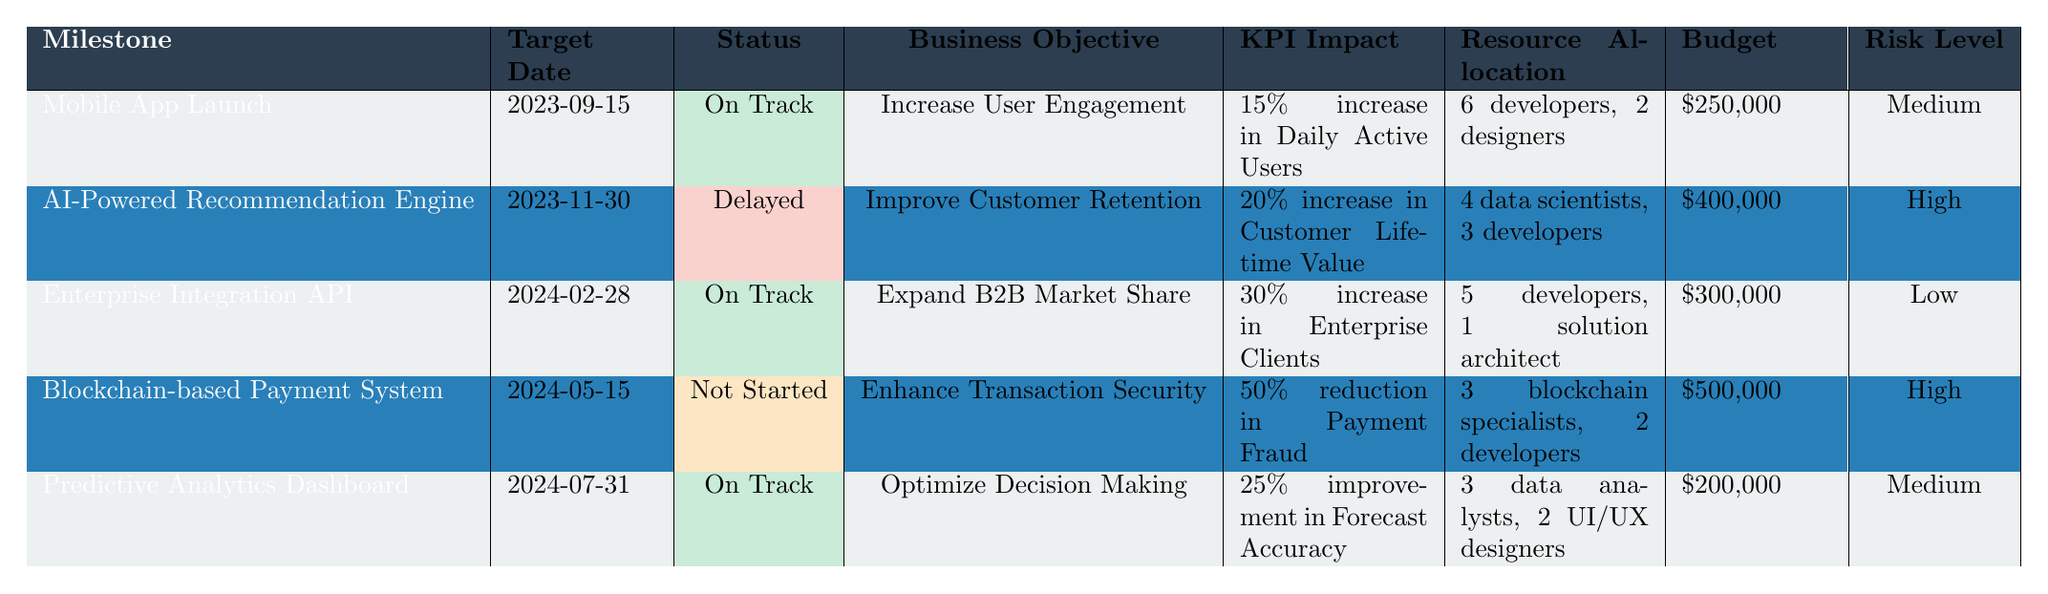What is the target date for the "AI-Powered Recommendation Engine"? The target date is specifically listed in the table. It is found under the corresponding row for the "AI-Powered Recommendation Engine".
Answer: 2023-11-30 Which milestone has the highest budget allocation? By comparing the budget values for all milestones in the table, the "Blockchain-based Payment System" has a budget of $500,000, which is higher than all others.
Answer: $500,000 Are there any milestones at high risk? The "AI-Powered Recommendation Engine" and the "Blockchain-based Payment System" have a risk level classified as High, as seen in the table under their respective rows.
Answer: Yes What is the total number of developers allocated across all milestones? The total number of developers can be calculated by summing the developers allocated for each milestone: 6 + 3 + 5 + 2 + 2 = 18.
Answer: 18 developers What percentage increase in Customer Lifetime Value is expected from the AI-Powered Recommendation Engine? The KPI Impact for the AI-Powered Recommendation Engine specifically states a 20% increase in Customer Lifetime Value, as listed in the table.
Answer: 20% Which milestone has the earliest target date, and what is that date? By examining the target dates of all milestones, the earliest date is for the "Mobile App Launch" on 2023-09-15, found in the first row.
Answer: 2023-09-15 If the Blockchain-based Payment System is delayed, what would the cumulative budget required for all "On Track" milestones be? The milestones that are "On Track" are "Mobile App Launch", "Enterprise Integration API", and "Predictive Analytics Dashboard", with respective budgets of $250,000 + $300,000 + $200,000, totalling $750,000.
Answer: $750,000 Is it true that all milestones align with business objectives of increasing some performance metric? Checking each milestone's business objective against the impact, all are linked to increasing a specific performance metric (like engagement, retention, market share, etc.), thus making the statement true.
Answer: Yes What is the overall average budget allocation for the milestones? The total budget is $250,000 + $400,000 + $300,000 + $500,000 + $200,000 = $1,650,000. Dividing by 5 milestones gives an average budget of $330,000.
Answer: $330,000 Which milestone aims to reduce payment fraud and what is the expected percentage reduction? The milestone focused on reducing payment fraud is the "Blockchain-based Payment System", with an expected reduction of 50%, explicitly mentioned in the table.
Answer: 50% 